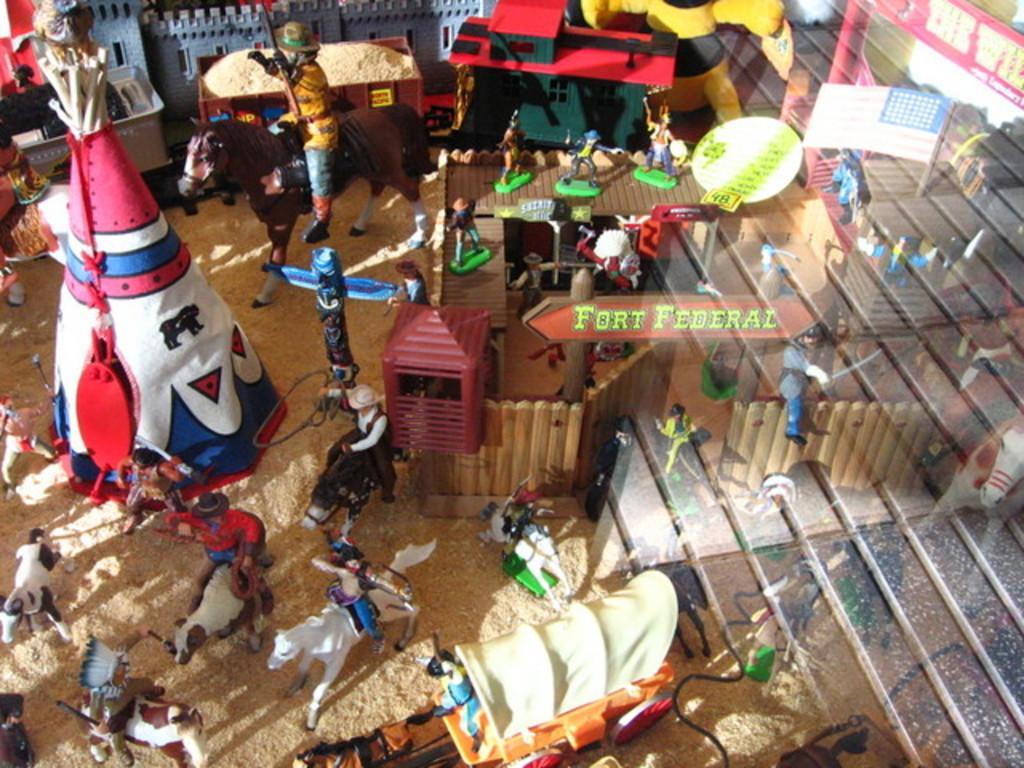Could you give a brief overview of what you see in this image? In this image I see the miniature set of toys and I see few horses on which there are persons sitting and I see houses and I see a board on which there are 2 words written and I see the ground and I see a colorful thing over here and I see a cart over here. 